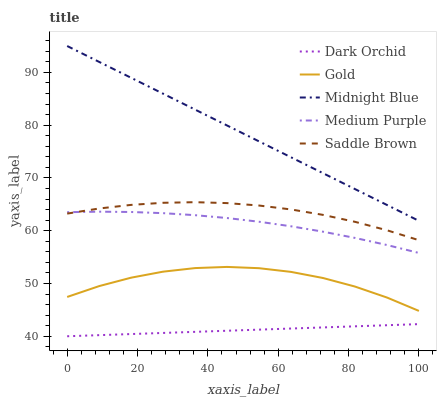Does Dark Orchid have the minimum area under the curve?
Answer yes or no. Yes. Does Midnight Blue have the maximum area under the curve?
Answer yes or no. Yes. Does Saddle Brown have the minimum area under the curve?
Answer yes or no. No. Does Saddle Brown have the maximum area under the curve?
Answer yes or no. No. Is Dark Orchid the smoothest?
Answer yes or no. Yes. Is Gold the roughest?
Answer yes or no. Yes. Is Saddle Brown the smoothest?
Answer yes or no. No. Is Saddle Brown the roughest?
Answer yes or no. No. Does Saddle Brown have the lowest value?
Answer yes or no. No. Does Saddle Brown have the highest value?
Answer yes or no. No. Is Gold less than Midnight Blue?
Answer yes or no. Yes. Is Midnight Blue greater than Medium Purple?
Answer yes or no. Yes. Does Gold intersect Midnight Blue?
Answer yes or no. No. 